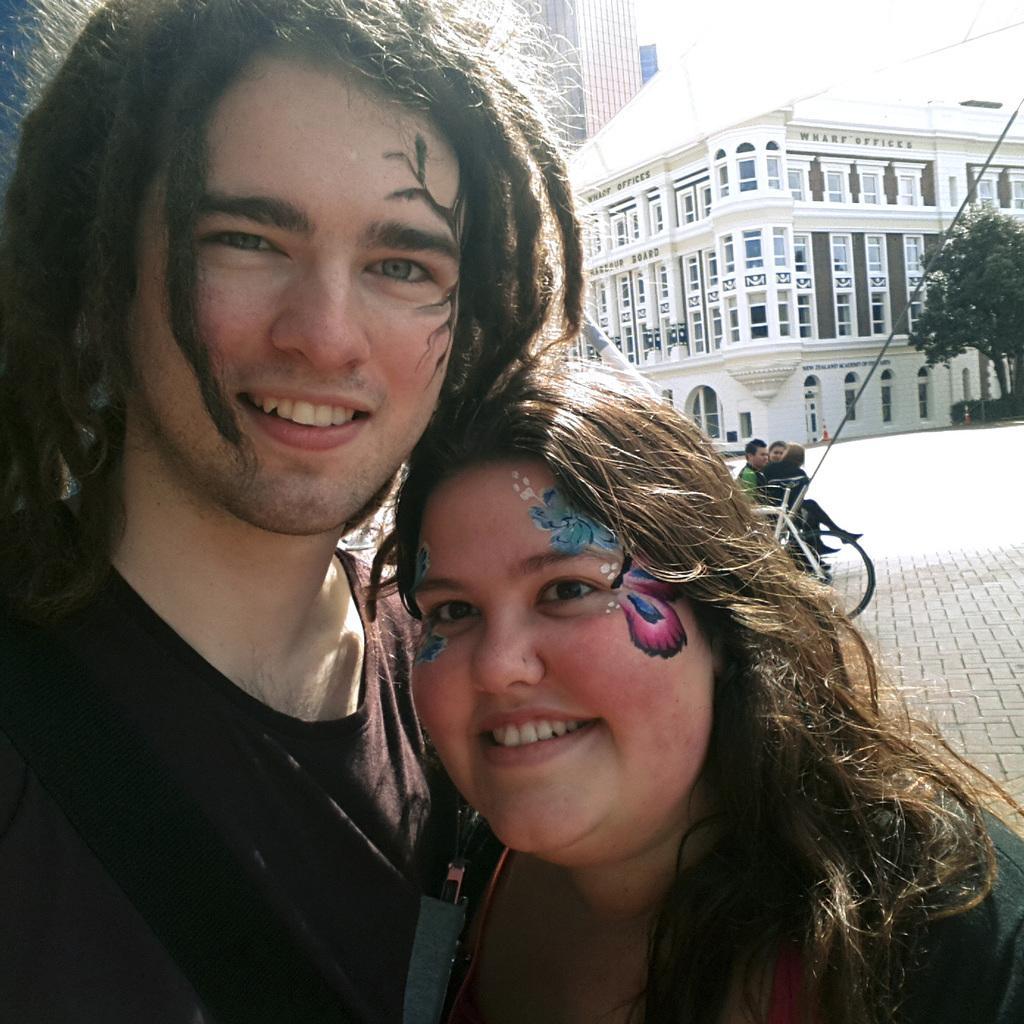How would you summarize this image in a sentence or two? In this image we can see a man and a woman. On the backside we can see a vehicle, some people sitting, some poles, the buildings and a tree. 